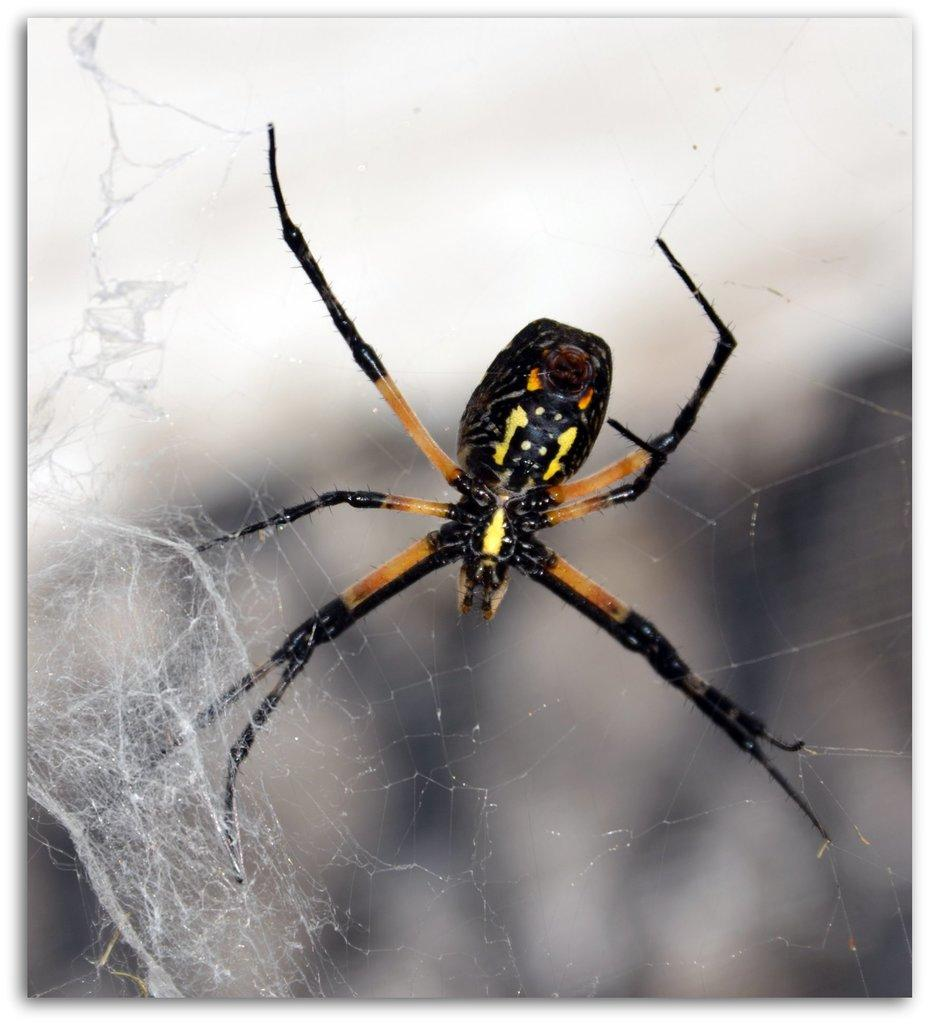What is the main subject of the picture? The main subject of the picture is a spider. What are the spider's physical features? The spider has legs and a body. What is surrounding the spider? There is a web around the spider. Can you describe the background of the image? The backdrop of the image is blurred. What type of pot is placed on the table in the image? There is no pot or table present in the image; it features a spider with a web. How is the division between the spider and the web represented in the image? The image does not depict a division between the spider and the web; they are integrated into one another. 